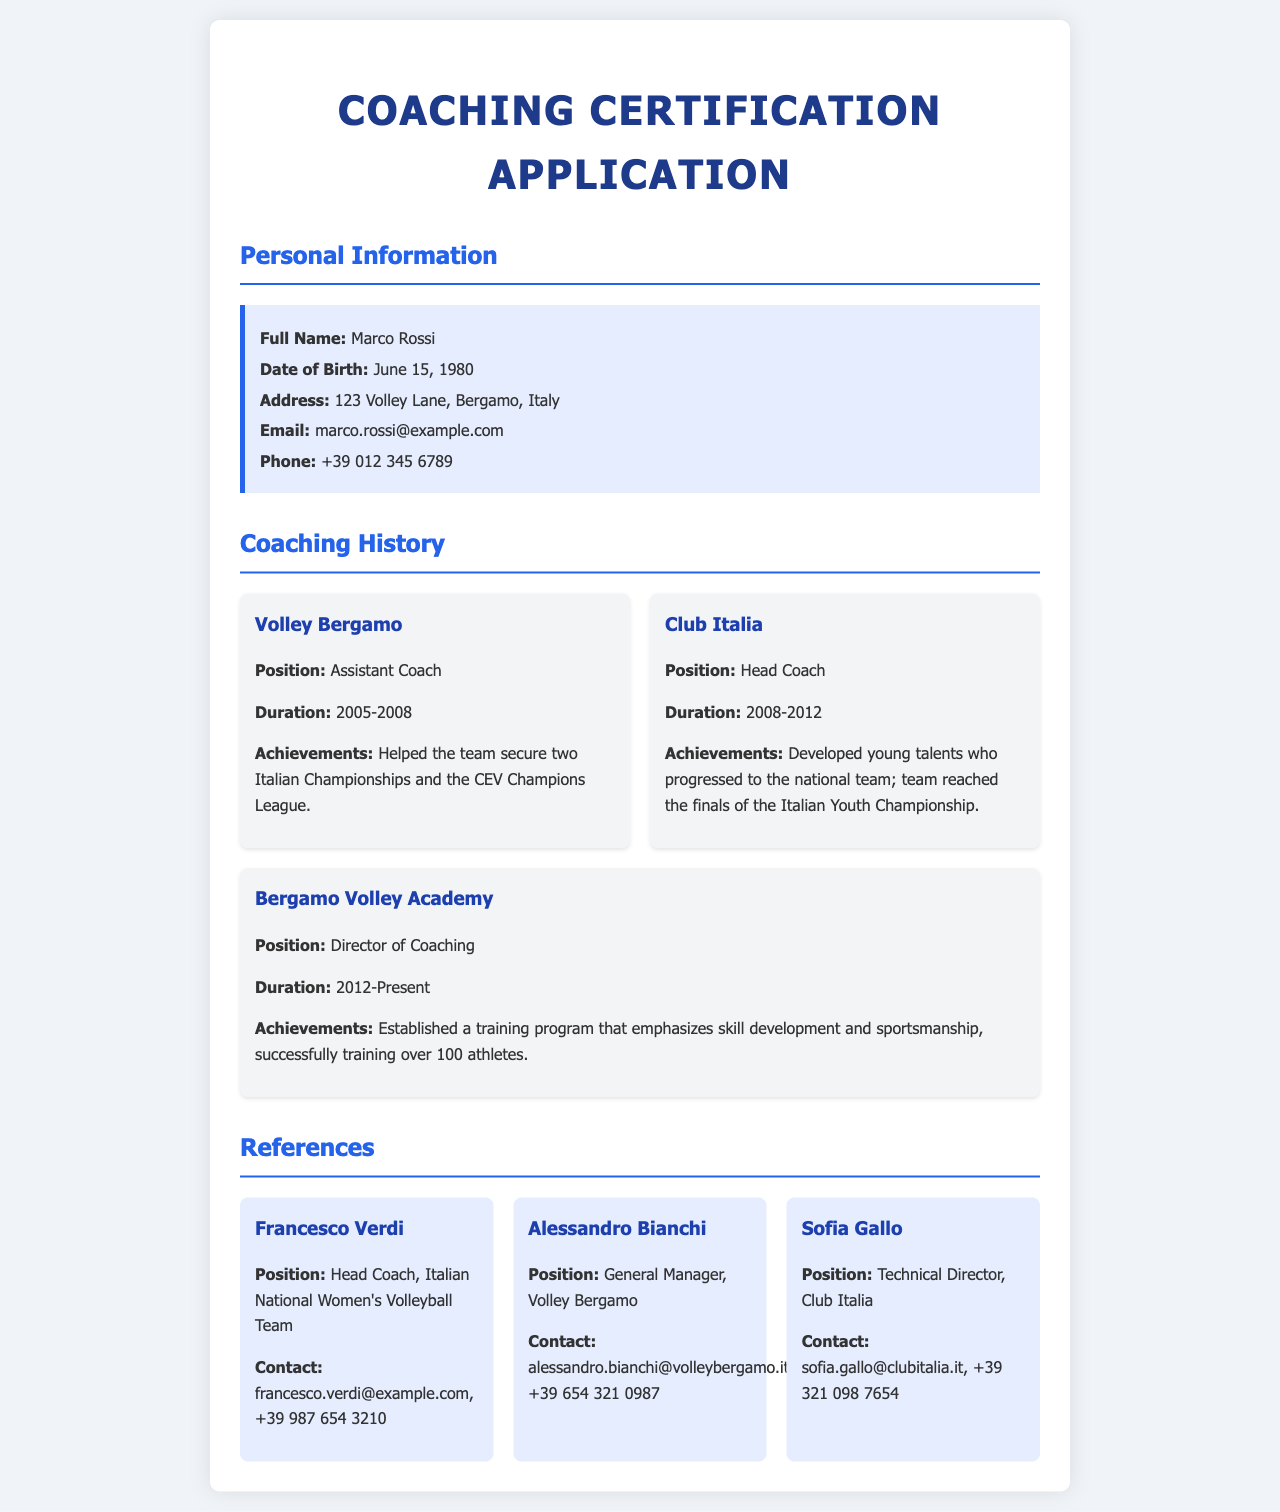what is the full name of the applicant? The applicant's full name is listed in the personal information section.
Answer: Marco Rossi what is the date of birth of the applicant? The date of birth is specified under personal information near the top of the document.
Answer: June 15, 1980 what is the position held at Volley Bergamo? The position is detailed in the coaching history section for Volley Bergamo.
Answer: Assistant Coach how many years did the applicant serve as Head Coach at Club Italia? The duration of service at Club Italia is mentioned, calculating from 2008 to 2012.
Answer: 4 years what achievements are noted for the applicant's role in Volley Bergamo? The achievements are outlined under the coaching history for Volley Bergamo.
Answer: Two Italian Championships and the CEV Champions League who is the applicant's reference from the Italian National Women's Volleyball Team? The references section lists individuals and their roles.
Answer: Francesco Verdi what is the contact email for Alessandro Bianchi? The contact information for each reference is provided, including emails.
Answer: alessandro.bianchi@volleybergamo.it which role is currently held by the applicant at Bergamo Volley Academy? The applicant's current position is specified in the coaching history section.
Answer: Director of Coaching how many athletes have been successfully trained in the current role? The total number of athletes trained is mentioned in the coaching history for Bergamo Volley Academy.
Answer: Over 100 athletes 